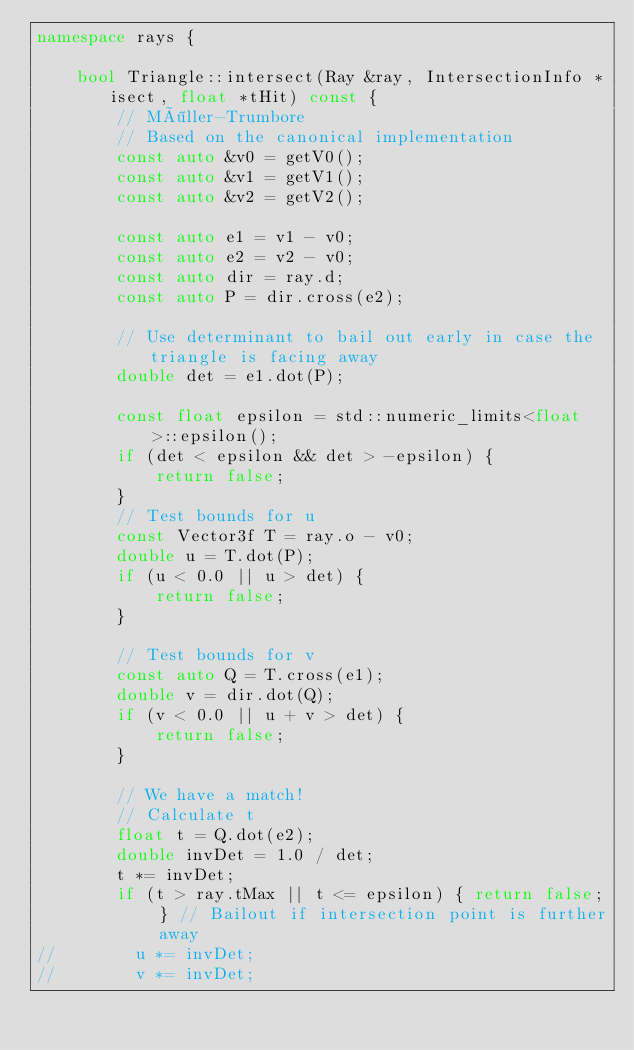Convert code to text. <code><loc_0><loc_0><loc_500><loc_500><_C++_>namespace rays {

    bool Triangle::intersect(Ray &ray, IntersectionInfo *isect, float *tHit) const {
        // Möller-Trumbore
        // Based on the canonical implementation
        const auto &v0 = getV0();
        const auto &v1 = getV1();
        const auto &v2 = getV2();

        const auto e1 = v1 - v0;
        const auto e2 = v2 - v0;
        const auto dir = ray.d;
        const auto P = dir.cross(e2);

        // Use determinant to bail out early in case the triangle is facing away
        double det = e1.dot(P);

        const float epsilon = std::numeric_limits<float>::epsilon();
        if (det < epsilon && det > -epsilon) {
            return false;
        }
        // Test bounds for u
        const Vector3f T = ray.o - v0;
        double u = T.dot(P);
        if (u < 0.0 || u > det) {
            return false;
        }

        // Test bounds for v
        const auto Q = T.cross(e1);
        double v = dir.dot(Q);
        if (v < 0.0 || u + v > det) {
            return false;
        }

        // We have a match!
        // Calculate t
        float t = Q.dot(e2);
        double invDet = 1.0 / det;
        t *= invDet;
        if (t > ray.tMax || t <= epsilon) { return false; } // Bailout if intersection point is further away
//        u *= invDet;
//        v *= invDet;
</code> 